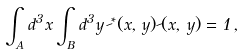Convert formula to latex. <formula><loc_0><loc_0><loc_500><loc_500>\int _ { _ { A } } d ^ { 3 } x \int _ { _ { B } } d ^ { 3 } y \, \psi ^ { * } ( x , \, y ) \psi ( x , \, y ) = 1 \, ,</formula> 